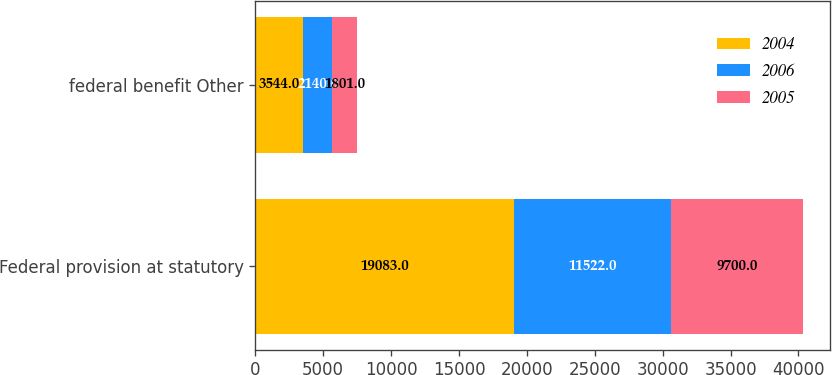Convert chart to OTSL. <chart><loc_0><loc_0><loc_500><loc_500><stacked_bar_chart><ecel><fcel>Federal provision at statutory<fcel>federal benefit Other<nl><fcel>2004<fcel>19083<fcel>3544<nl><fcel>2006<fcel>11522<fcel>2140<nl><fcel>2005<fcel>9700<fcel>1801<nl></chart> 